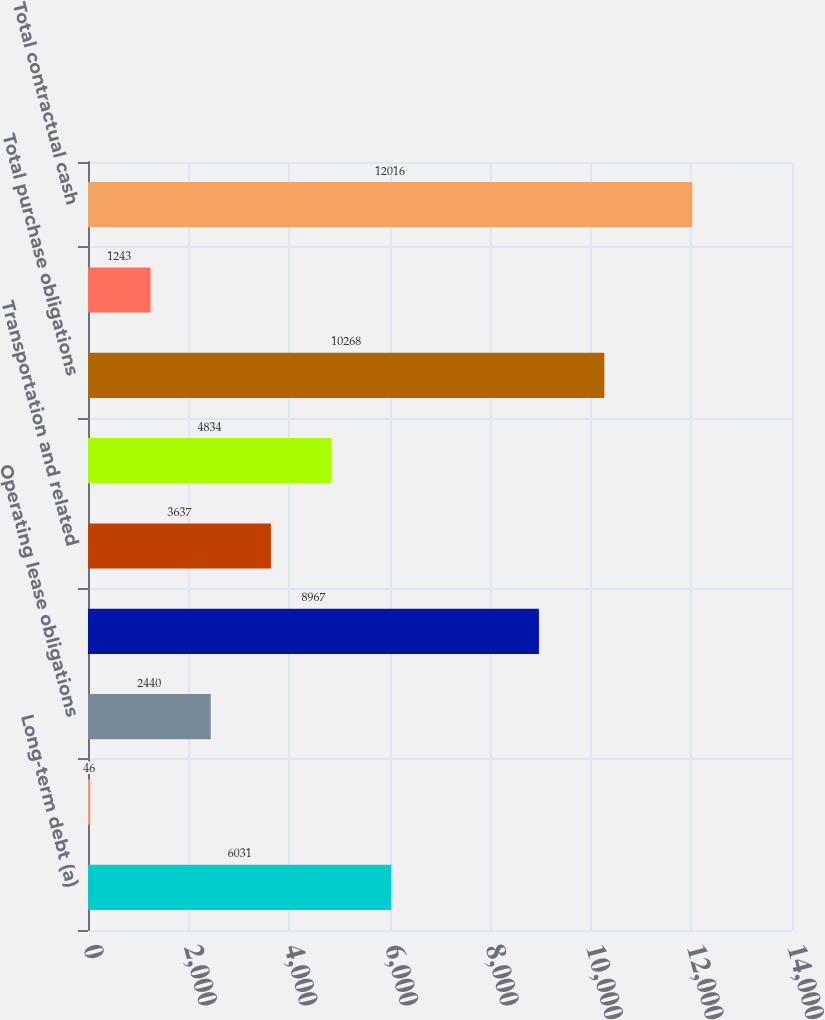Convert chart to OTSL. <chart><loc_0><loc_0><loc_500><loc_500><bar_chart><fcel>Long-term debt (a)<fcel>Capital lease obligations (b)<fcel>Operating lease obligations<fcel>Crude oil feedstock refined<fcel>Transportation and related<fcel>Service materials and other<fcel>Total purchase obligations<fcel>Other long-term liabilities<fcel>Total contractual cash<nl><fcel>6031<fcel>46<fcel>2440<fcel>8967<fcel>3637<fcel>4834<fcel>10268<fcel>1243<fcel>12016<nl></chart> 